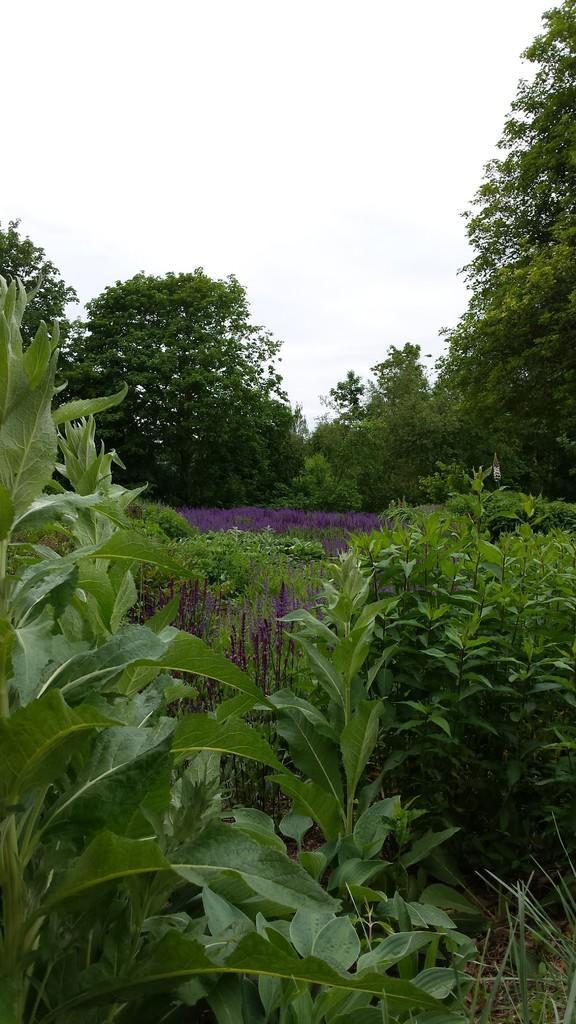What type of vegetation is present on the ground in the image? There are plants on the ground in the image. What other type of vegetation can be seen in the image? There are trees in the image. What can be seen in the background of the image? The sky is visible in the background of the image. What riddle can be solved by observing the plants in the image? There is no riddle present in the image. The image only features plants on the ground, trees, and the sky in the background. --- Facts: 1. There is a car in the image. 2. The car is red. 3. The car has four wheels. 4. The car is parked on the street. 5. There are people walking on the sidewalk. Absurd Topics: unicorn, magic wand, flying carpet Conversation: What type of vehicle is in the image? There is a car in the image. What color is the car? The car is red. How many wheels does the car have? The car has four wheels. Where is the car located in the image? The car is parked on the street. What else can be seen in the image? There are people walking on the sidewalk. Reasoning: Let's think step by step in order to produce the conversation. We start by identifying the main subject of the image, which is the car. Next, we describe specific features of the car, such as its color and the number of wheels it has. Then, we observe the car's location in the image, which is parked on the street. After that, we expand the conversation to include other elements present in the image, such as the people walking on the sidewalk. Absurd Question/Answer: Can you see a unicorn in the image? No, there is no unicorn present in the image. The image only features a red car parked on the street and people walking on the sidewalk. --- Facts: 1. There is a group of people in the image. 2. The people are wearing hats. 3. The people are holding hands. 4. The people are standing in a circle. 5. There is a sign in the center of the circle. Absurd Topics: giant squid, underwater city, mermaid Conversation: How many people are in the image? There is a group of people in the image. What are the people wearing on their heads? The people are wearing hats. What are the people doing in the image? The people are holding hands and standing in a circle. What can be seen in the center of the circle? There is a sign in the center of the circle. Reasoning: Let's think step by step in order to produce the conversation. We start by identifying the main subject of the image, which is the group of people. Next, we describe specific features 